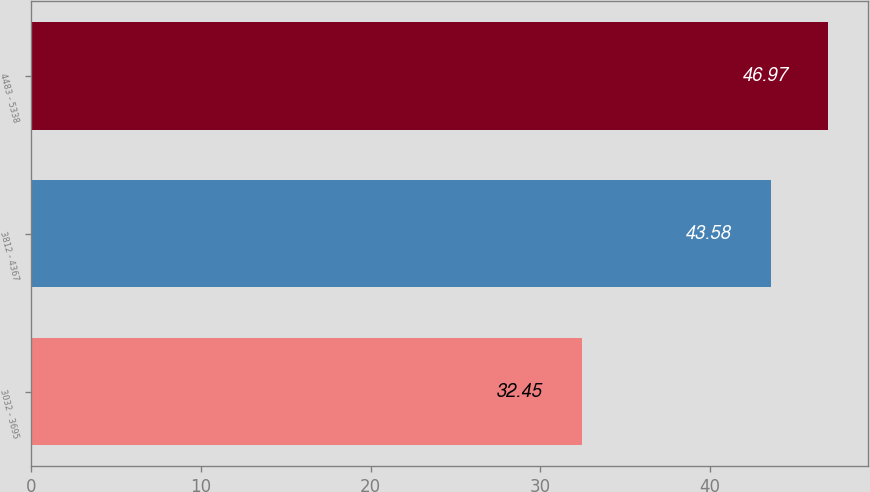<chart> <loc_0><loc_0><loc_500><loc_500><bar_chart><fcel>3032 - 3695<fcel>3812 - 4367<fcel>4483 - 5338<nl><fcel>32.45<fcel>43.58<fcel>46.97<nl></chart> 